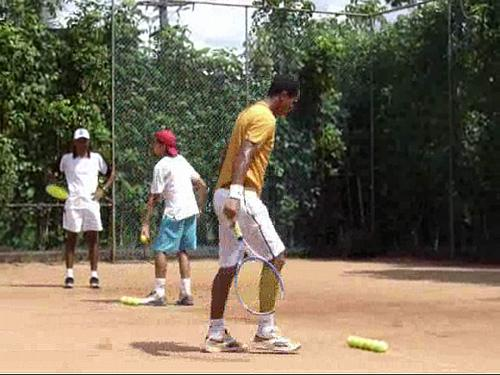What is the man looking down at? Please explain your reasoning. tennis balls. The color and the fact they are on a tennis court, it's easy to understand what the balls are. 